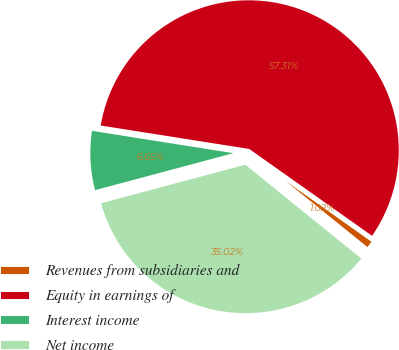Convert chart to OTSL. <chart><loc_0><loc_0><loc_500><loc_500><pie_chart><fcel>Revenues from subsidiaries and<fcel>Equity in earnings of<fcel>Interest income<fcel>Net income<nl><fcel>1.02%<fcel>57.3%<fcel>6.65%<fcel>35.02%<nl></chart> 